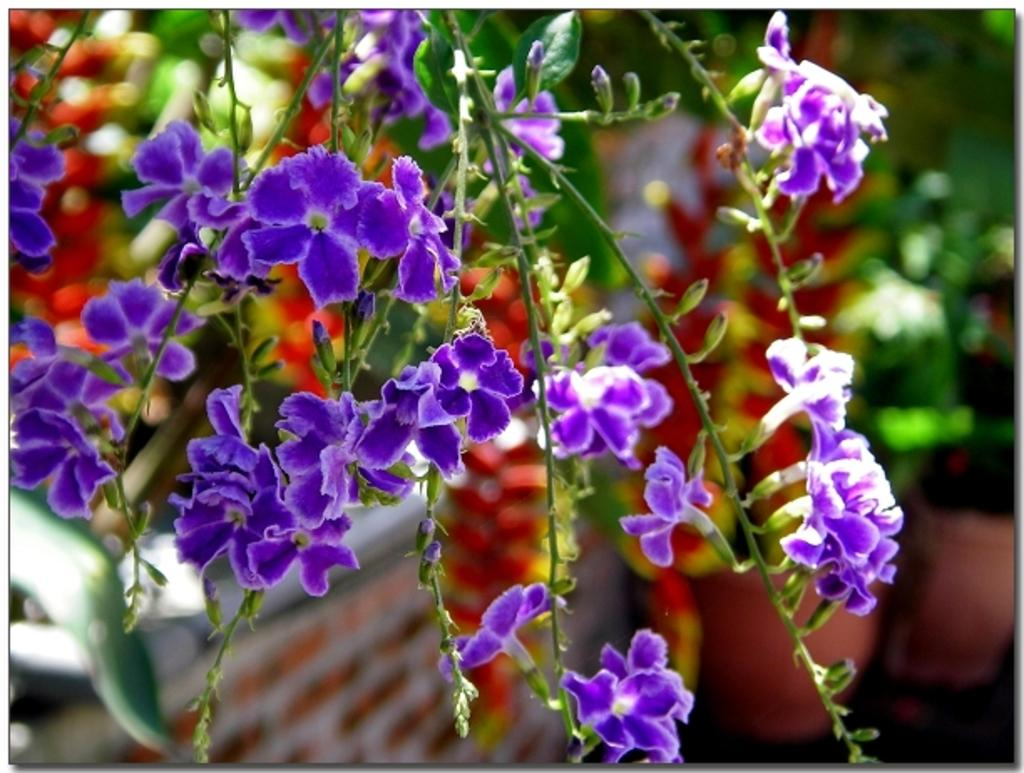What color are the flowers on the plant in the image? The flowers on the plant are purple. What can be seen behind the plant in the image? There is a wall at the back of the image. How are the plants arranged in the image? The plants are in pots in the image. Can you see a glass of water on the plant in the image? There is no glass of water present in the image. 